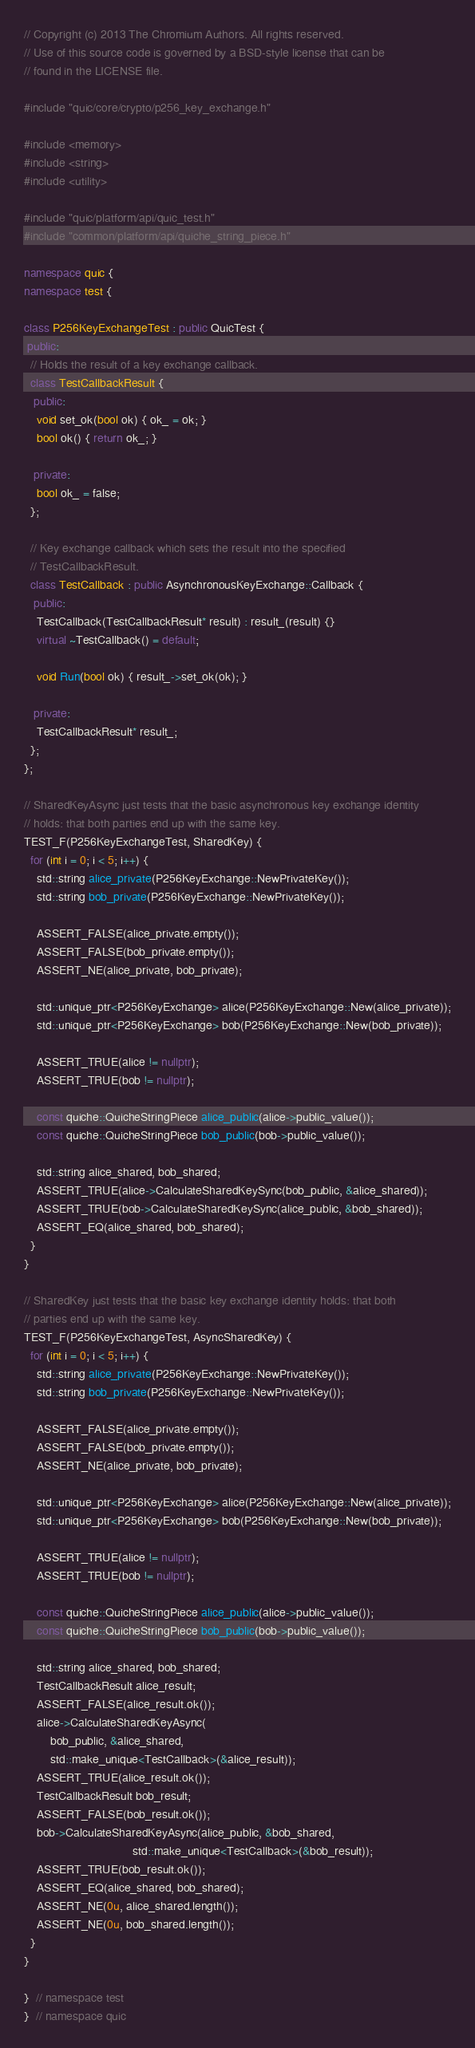Convert code to text. <code><loc_0><loc_0><loc_500><loc_500><_C++_>// Copyright (c) 2013 The Chromium Authors. All rights reserved.
// Use of this source code is governed by a BSD-style license that can be
// found in the LICENSE file.

#include "quic/core/crypto/p256_key_exchange.h"

#include <memory>
#include <string>
#include <utility>

#include "quic/platform/api/quic_test.h"
#include "common/platform/api/quiche_string_piece.h"

namespace quic {
namespace test {

class P256KeyExchangeTest : public QuicTest {
 public:
  // Holds the result of a key exchange callback.
  class TestCallbackResult {
   public:
    void set_ok(bool ok) { ok_ = ok; }
    bool ok() { return ok_; }

   private:
    bool ok_ = false;
  };

  // Key exchange callback which sets the result into the specified
  // TestCallbackResult.
  class TestCallback : public AsynchronousKeyExchange::Callback {
   public:
    TestCallback(TestCallbackResult* result) : result_(result) {}
    virtual ~TestCallback() = default;

    void Run(bool ok) { result_->set_ok(ok); }

   private:
    TestCallbackResult* result_;
  };
};

// SharedKeyAsync just tests that the basic asynchronous key exchange identity
// holds: that both parties end up with the same key.
TEST_F(P256KeyExchangeTest, SharedKey) {
  for (int i = 0; i < 5; i++) {
    std::string alice_private(P256KeyExchange::NewPrivateKey());
    std::string bob_private(P256KeyExchange::NewPrivateKey());

    ASSERT_FALSE(alice_private.empty());
    ASSERT_FALSE(bob_private.empty());
    ASSERT_NE(alice_private, bob_private);

    std::unique_ptr<P256KeyExchange> alice(P256KeyExchange::New(alice_private));
    std::unique_ptr<P256KeyExchange> bob(P256KeyExchange::New(bob_private));

    ASSERT_TRUE(alice != nullptr);
    ASSERT_TRUE(bob != nullptr);

    const quiche::QuicheStringPiece alice_public(alice->public_value());
    const quiche::QuicheStringPiece bob_public(bob->public_value());

    std::string alice_shared, bob_shared;
    ASSERT_TRUE(alice->CalculateSharedKeySync(bob_public, &alice_shared));
    ASSERT_TRUE(bob->CalculateSharedKeySync(alice_public, &bob_shared));
    ASSERT_EQ(alice_shared, bob_shared);
  }
}

// SharedKey just tests that the basic key exchange identity holds: that both
// parties end up with the same key.
TEST_F(P256KeyExchangeTest, AsyncSharedKey) {
  for (int i = 0; i < 5; i++) {
    std::string alice_private(P256KeyExchange::NewPrivateKey());
    std::string bob_private(P256KeyExchange::NewPrivateKey());

    ASSERT_FALSE(alice_private.empty());
    ASSERT_FALSE(bob_private.empty());
    ASSERT_NE(alice_private, bob_private);

    std::unique_ptr<P256KeyExchange> alice(P256KeyExchange::New(alice_private));
    std::unique_ptr<P256KeyExchange> bob(P256KeyExchange::New(bob_private));

    ASSERT_TRUE(alice != nullptr);
    ASSERT_TRUE(bob != nullptr);

    const quiche::QuicheStringPiece alice_public(alice->public_value());
    const quiche::QuicheStringPiece bob_public(bob->public_value());

    std::string alice_shared, bob_shared;
    TestCallbackResult alice_result;
    ASSERT_FALSE(alice_result.ok());
    alice->CalculateSharedKeyAsync(
        bob_public, &alice_shared,
        std::make_unique<TestCallback>(&alice_result));
    ASSERT_TRUE(alice_result.ok());
    TestCallbackResult bob_result;
    ASSERT_FALSE(bob_result.ok());
    bob->CalculateSharedKeyAsync(alice_public, &bob_shared,
                                 std::make_unique<TestCallback>(&bob_result));
    ASSERT_TRUE(bob_result.ok());
    ASSERT_EQ(alice_shared, bob_shared);
    ASSERT_NE(0u, alice_shared.length());
    ASSERT_NE(0u, bob_shared.length());
  }
}

}  // namespace test
}  // namespace quic
</code> 